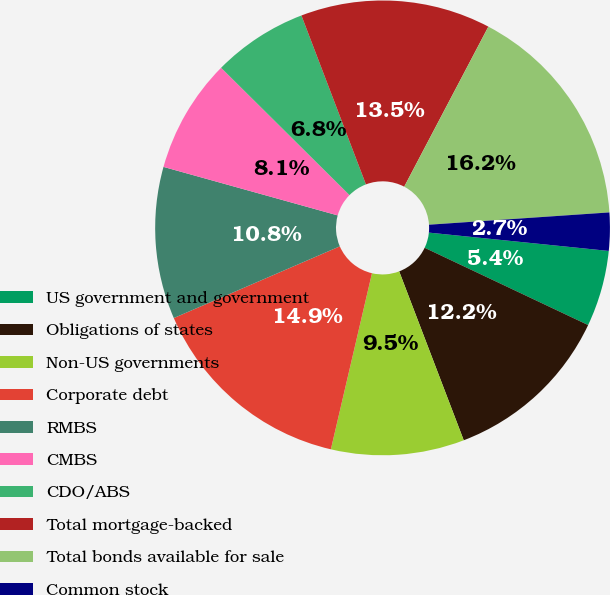Convert chart to OTSL. <chart><loc_0><loc_0><loc_500><loc_500><pie_chart><fcel>US government and government<fcel>Obligations of states<fcel>Non-US governments<fcel>Corporate debt<fcel>RMBS<fcel>CMBS<fcel>CDO/ABS<fcel>Total mortgage-backed<fcel>Total bonds available for sale<fcel>Common stock<nl><fcel>5.41%<fcel>12.16%<fcel>9.46%<fcel>14.86%<fcel>10.81%<fcel>8.11%<fcel>6.76%<fcel>13.51%<fcel>16.21%<fcel>2.7%<nl></chart> 